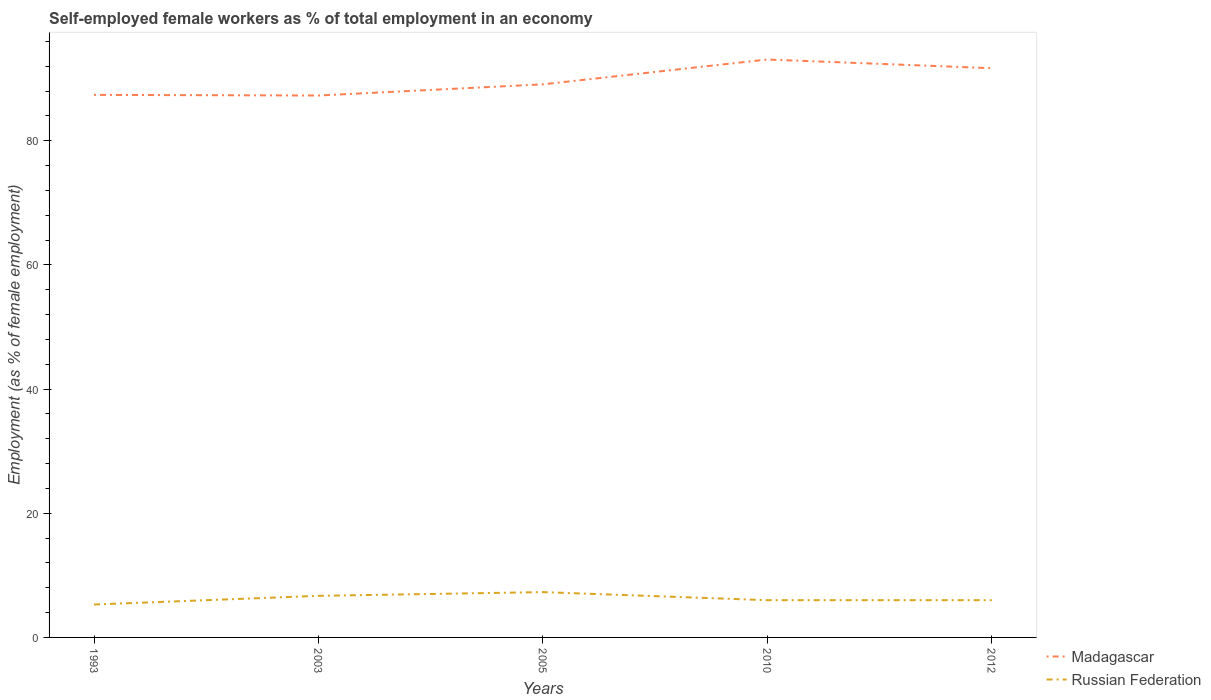Across all years, what is the maximum percentage of self-employed female workers in Madagascar?
Offer a terse response. 87.3. What is the total percentage of self-employed female workers in Russian Federation in the graph?
Your answer should be compact. 1.3. What is the difference between the highest and the second highest percentage of self-employed female workers in Madagascar?
Offer a very short reply. 5.8. What is the difference between the highest and the lowest percentage of self-employed female workers in Madagascar?
Keep it short and to the point. 2. How many years are there in the graph?
Keep it short and to the point. 5. Where does the legend appear in the graph?
Provide a short and direct response. Bottom right. How are the legend labels stacked?
Ensure brevity in your answer.  Vertical. What is the title of the graph?
Provide a short and direct response. Self-employed female workers as % of total employment in an economy. What is the label or title of the X-axis?
Offer a terse response. Years. What is the label or title of the Y-axis?
Ensure brevity in your answer.  Employment (as % of female employment). What is the Employment (as % of female employment) of Madagascar in 1993?
Your response must be concise. 87.4. What is the Employment (as % of female employment) of Russian Federation in 1993?
Keep it short and to the point. 5.3. What is the Employment (as % of female employment) of Madagascar in 2003?
Your answer should be very brief. 87.3. What is the Employment (as % of female employment) in Russian Federation in 2003?
Give a very brief answer. 6.7. What is the Employment (as % of female employment) in Madagascar in 2005?
Make the answer very short. 89.1. What is the Employment (as % of female employment) in Russian Federation in 2005?
Offer a terse response. 7.3. What is the Employment (as % of female employment) of Madagascar in 2010?
Your answer should be very brief. 93.1. What is the Employment (as % of female employment) of Russian Federation in 2010?
Make the answer very short. 6. What is the Employment (as % of female employment) in Madagascar in 2012?
Your answer should be compact. 91.7. Across all years, what is the maximum Employment (as % of female employment) in Madagascar?
Ensure brevity in your answer.  93.1. Across all years, what is the maximum Employment (as % of female employment) in Russian Federation?
Your response must be concise. 7.3. Across all years, what is the minimum Employment (as % of female employment) of Madagascar?
Your response must be concise. 87.3. Across all years, what is the minimum Employment (as % of female employment) in Russian Federation?
Make the answer very short. 5.3. What is the total Employment (as % of female employment) of Madagascar in the graph?
Offer a very short reply. 448.6. What is the total Employment (as % of female employment) of Russian Federation in the graph?
Make the answer very short. 31.3. What is the difference between the Employment (as % of female employment) in Madagascar in 1993 and that in 2003?
Keep it short and to the point. 0.1. What is the difference between the Employment (as % of female employment) in Russian Federation in 1993 and that in 2003?
Your response must be concise. -1.4. What is the difference between the Employment (as % of female employment) of Russian Federation in 1993 and that in 2005?
Your response must be concise. -2. What is the difference between the Employment (as % of female employment) in Russian Federation in 1993 and that in 2010?
Offer a very short reply. -0.7. What is the difference between the Employment (as % of female employment) of Russian Federation in 1993 and that in 2012?
Provide a short and direct response. -0.7. What is the difference between the Employment (as % of female employment) of Russian Federation in 2003 and that in 2005?
Offer a terse response. -0.6. What is the difference between the Employment (as % of female employment) in Madagascar in 2003 and that in 2010?
Offer a terse response. -5.8. What is the difference between the Employment (as % of female employment) of Madagascar in 2003 and that in 2012?
Your answer should be compact. -4.4. What is the difference between the Employment (as % of female employment) in Russian Federation in 2003 and that in 2012?
Give a very brief answer. 0.7. What is the difference between the Employment (as % of female employment) of Madagascar in 2005 and that in 2010?
Make the answer very short. -4. What is the difference between the Employment (as % of female employment) in Russian Federation in 2005 and that in 2010?
Your response must be concise. 1.3. What is the difference between the Employment (as % of female employment) in Madagascar in 2005 and that in 2012?
Ensure brevity in your answer.  -2.6. What is the difference between the Employment (as % of female employment) of Madagascar in 2010 and that in 2012?
Make the answer very short. 1.4. What is the difference between the Employment (as % of female employment) in Russian Federation in 2010 and that in 2012?
Make the answer very short. 0. What is the difference between the Employment (as % of female employment) in Madagascar in 1993 and the Employment (as % of female employment) in Russian Federation in 2003?
Your answer should be compact. 80.7. What is the difference between the Employment (as % of female employment) of Madagascar in 1993 and the Employment (as % of female employment) of Russian Federation in 2005?
Provide a short and direct response. 80.1. What is the difference between the Employment (as % of female employment) in Madagascar in 1993 and the Employment (as % of female employment) in Russian Federation in 2010?
Your answer should be very brief. 81.4. What is the difference between the Employment (as % of female employment) in Madagascar in 1993 and the Employment (as % of female employment) in Russian Federation in 2012?
Offer a very short reply. 81.4. What is the difference between the Employment (as % of female employment) in Madagascar in 2003 and the Employment (as % of female employment) in Russian Federation in 2010?
Offer a very short reply. 81.3. What is the difference between the Employment (as % of female employment) of Madagascar in 2003 and the Employment (as % of female employment) of Russian Federation in 2012?
Give a very brief answer. 81.3. What is the difference between the Employment (as % of female employment) of Madagascar in 2005 and the Employment (as % of female employment) of Russian Federation in 2010?
Your answer should be very brief. 83.1. What is the difference between the Employment (as % of female employment) in Madagascar in 2005 and the Employment (as % of female employment) in Russian Federation in 2012?
Your answer should be compact. 83.1. What is the difference between the Employment (as % of female employment) in Madagascar in 2010 and the Employment (as % of female employment) in Russian Federation in 2012?
Provide a succinct answer. 87.1. What is the average Employment (as % of female employment) of Madagascar per year?
Ensure brevity in your answer.  89.72. What is the average Employment (as % of female employment) in Russian Federation per year?
Your answer should be very brief. 6.26. In the year 1993, what is the difference between the Employment (as % of female employment) of Madagascar and Employment (as % of female employment) of Russian Federation?
Your answer should be compact. 82.1. In the year 2003, what is the difference between the Employment (as % of female employment) of Madagascar and Employment (as % of female employment) of Russian Federation?
Your answer should be compact. 80.6. In the year 2005, what is the difference between the Employment (as % of female employment) of Madagascar and Employment (as % of female employment) of Russian Federation?
Make the answer very short. 81.8. In the year 2010, what is the difference between the Employment (as % of female employment) of Madagascar and Employment (as % of female employment) of Russian Federation?
Offer a terse response. 87.1. In the year 2012, what is the difference between the Employment (as % of female employment) in Madagascar and Employment (as % of female employment) in Russian Federation?
Keep it short and to the point. 85.7. What is the ratio of the Employment (as % of female employment) in Madagascar in 1993 to that in 2003?
Offer a terse response. 1. What is the ratio of the Employment (as % of female employment) in Russian Federation in 1993 to that in 2003?
Offer a terse response. 0.79. What is the ratio of the Employment (as % of female employment) of Madagascar in 1993 to that in 2005?
Keep it short and to the point. 0.98. What is the ratio of the Employment (as % of female employment) of Russian Federation in 1993 to that in 2005?
Ensure brevity in your answer.  0.73. What is the ratio of the Employment (as % of female employment) of Madagascar in 1993 to that in 2010?
Offer a very short reply. 0.94. What is the ratio of the Employment (as % of female employment) of Russian Federation in 1993 to that in 2010?
Your response must be concise. 0.88. What is the ratio of the Employment (as % of female employment) of Madagascar in 1993 to that in 2012?
Keep it short and to the point. 0.95. What is the ratio of the Employment (as % of female employment) in Russian Federation in 1993 to that in 2012?
Ensure brevity in your answer.  0.88. What is the ratio of the Employment (as % of female employment) in Madagascar in 2003 to that in 2005?
Provide a short and direct response. 0.98. What is the ratio of the Employment (as % of female employment) of Russian Federation in 2003 to that in 2005?
Provide a short and direct response. 0.92. What is the ratio of the Employment (as % of female employment) of Madagascar in 2003 to that in 2010?
Provide a succinct answer. 0.94. What is the ratio of the Employment (as % of female employment) of Russian Federation in 2003 to that in 2010?
Give a very brief answer. 1.12. What is the ratio of the Employment (as % of female employment) in Madagascar in 2003 to that in 2012?
Provide a short and direct response. 0.95. What is the ratio of the Employment (as % of female employment) of Russian Federation in 2003 to that in 2012?
Provide a succinct answer. 1.12. What is the ratio of the Employment (as % of female employment) in Russian Federation in 2005 to that in 2010?
Give a very brief answer. 1.22. What is the ratio of the Employment (as % of female employment) in Madagascar in 2005 to that in 2012?
Make the answer very short. 0.97. What is the ratio of the Employment (as % of female employment) of Russian Federation in 2005 to that in 2012?
Ensure brevity in your answer.  1.22. What is the ratio of the Employment (as % of female employment) in Madagascar in 2010 to that in 2012?
Keep it short and to the point. 1.02. What is the difference between the highest and the second highest Employment (as % of female employment) in Madagascar?
Make the answer very short. 1.4. What is the difference between the highest and the second highest Employment (as % of female employment) of Russian Federation?
Offer a terse response. 0.6. 